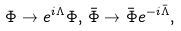Convert formula to latex. <formula><loc_0><loc_0><loc_500><loc_500>\Phi \rightarrow e ^ { i \Lambda } \Phi , \, \bar { \Phi } \rightarrow \bar { \Phi } e ^ { - i \bar { \Lambda } } ,</formula> 